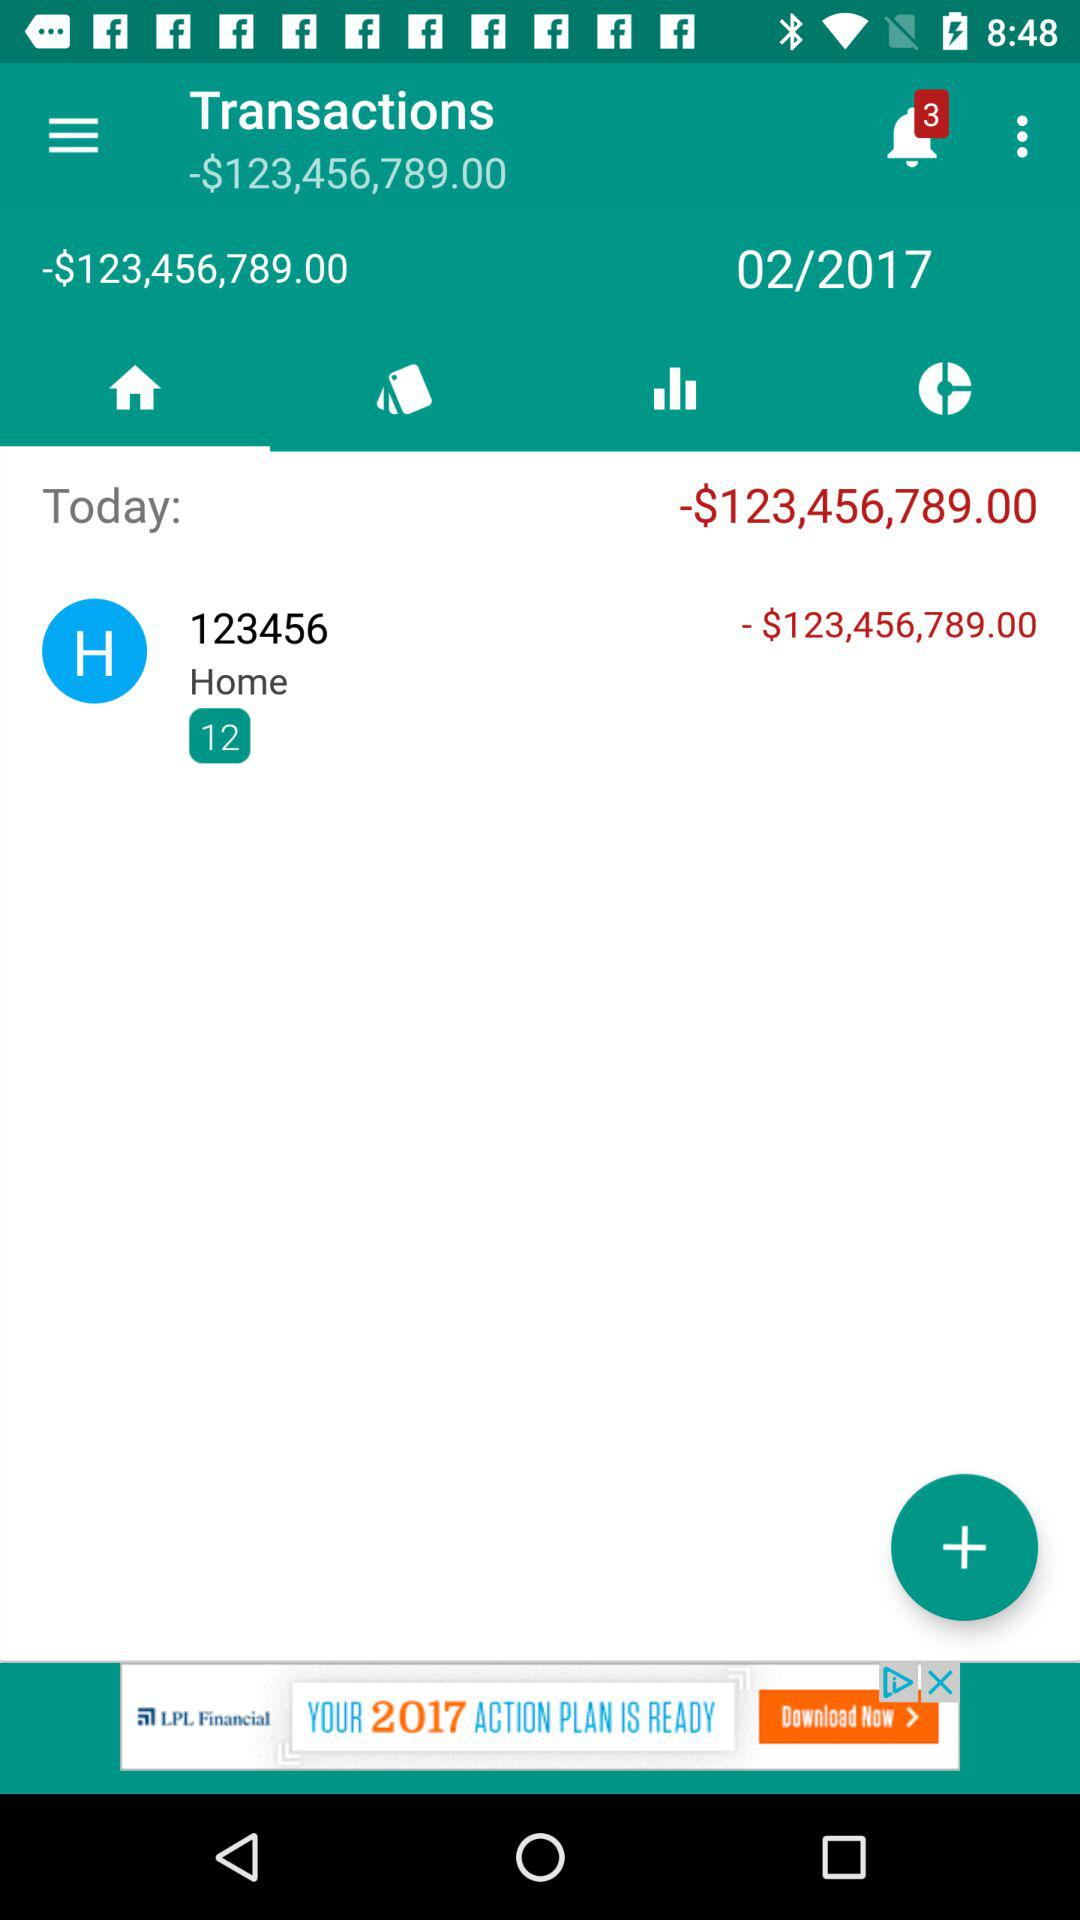How much money is in my account?
Answer the question using a single word or phrase. -$123,456,789.00 